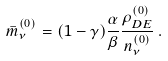<formula> <loc_0><loc_0><loc_500><loc_500>\bar { m } _ { \nu } ^ { ( 0 ) } = ( 1 - \gamma ) \frac { \alpha } { \beta } \frac { \rho _ { D E } ^ { ( 0 ) } } { n _ { \nu } ^ { ( 0 ) } } \, .</formula> 